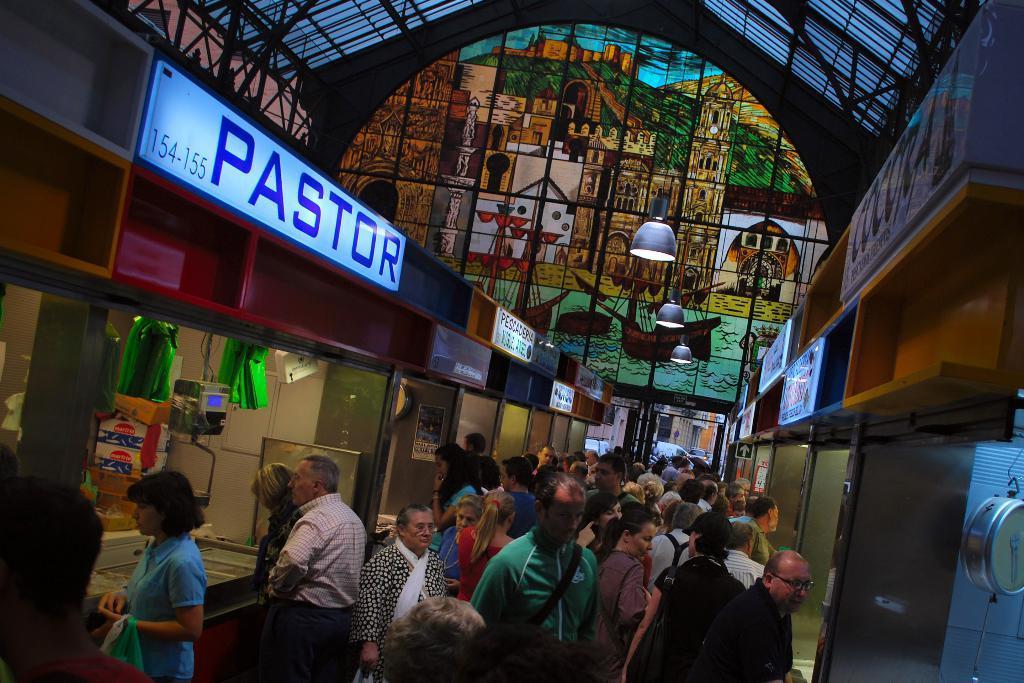Can you describe this image briefly? In this image we can see a group of people standing. We can also see some stalls containing bags, devices, a weighing machine and the sign boards with some text on them. We can also see the windows with the stained glass, a roof with some metal rods and the ceiling lamps. On the right bottom we can see a weighing machine. 